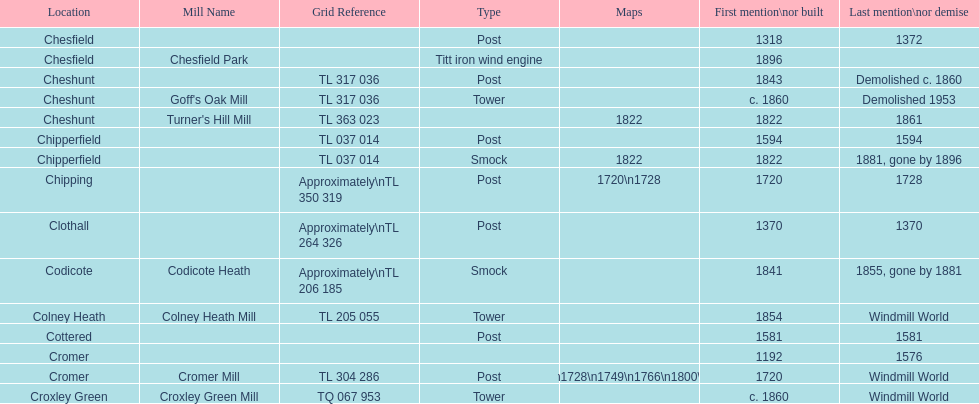What is the total number of mills named cheshunt? 3. 